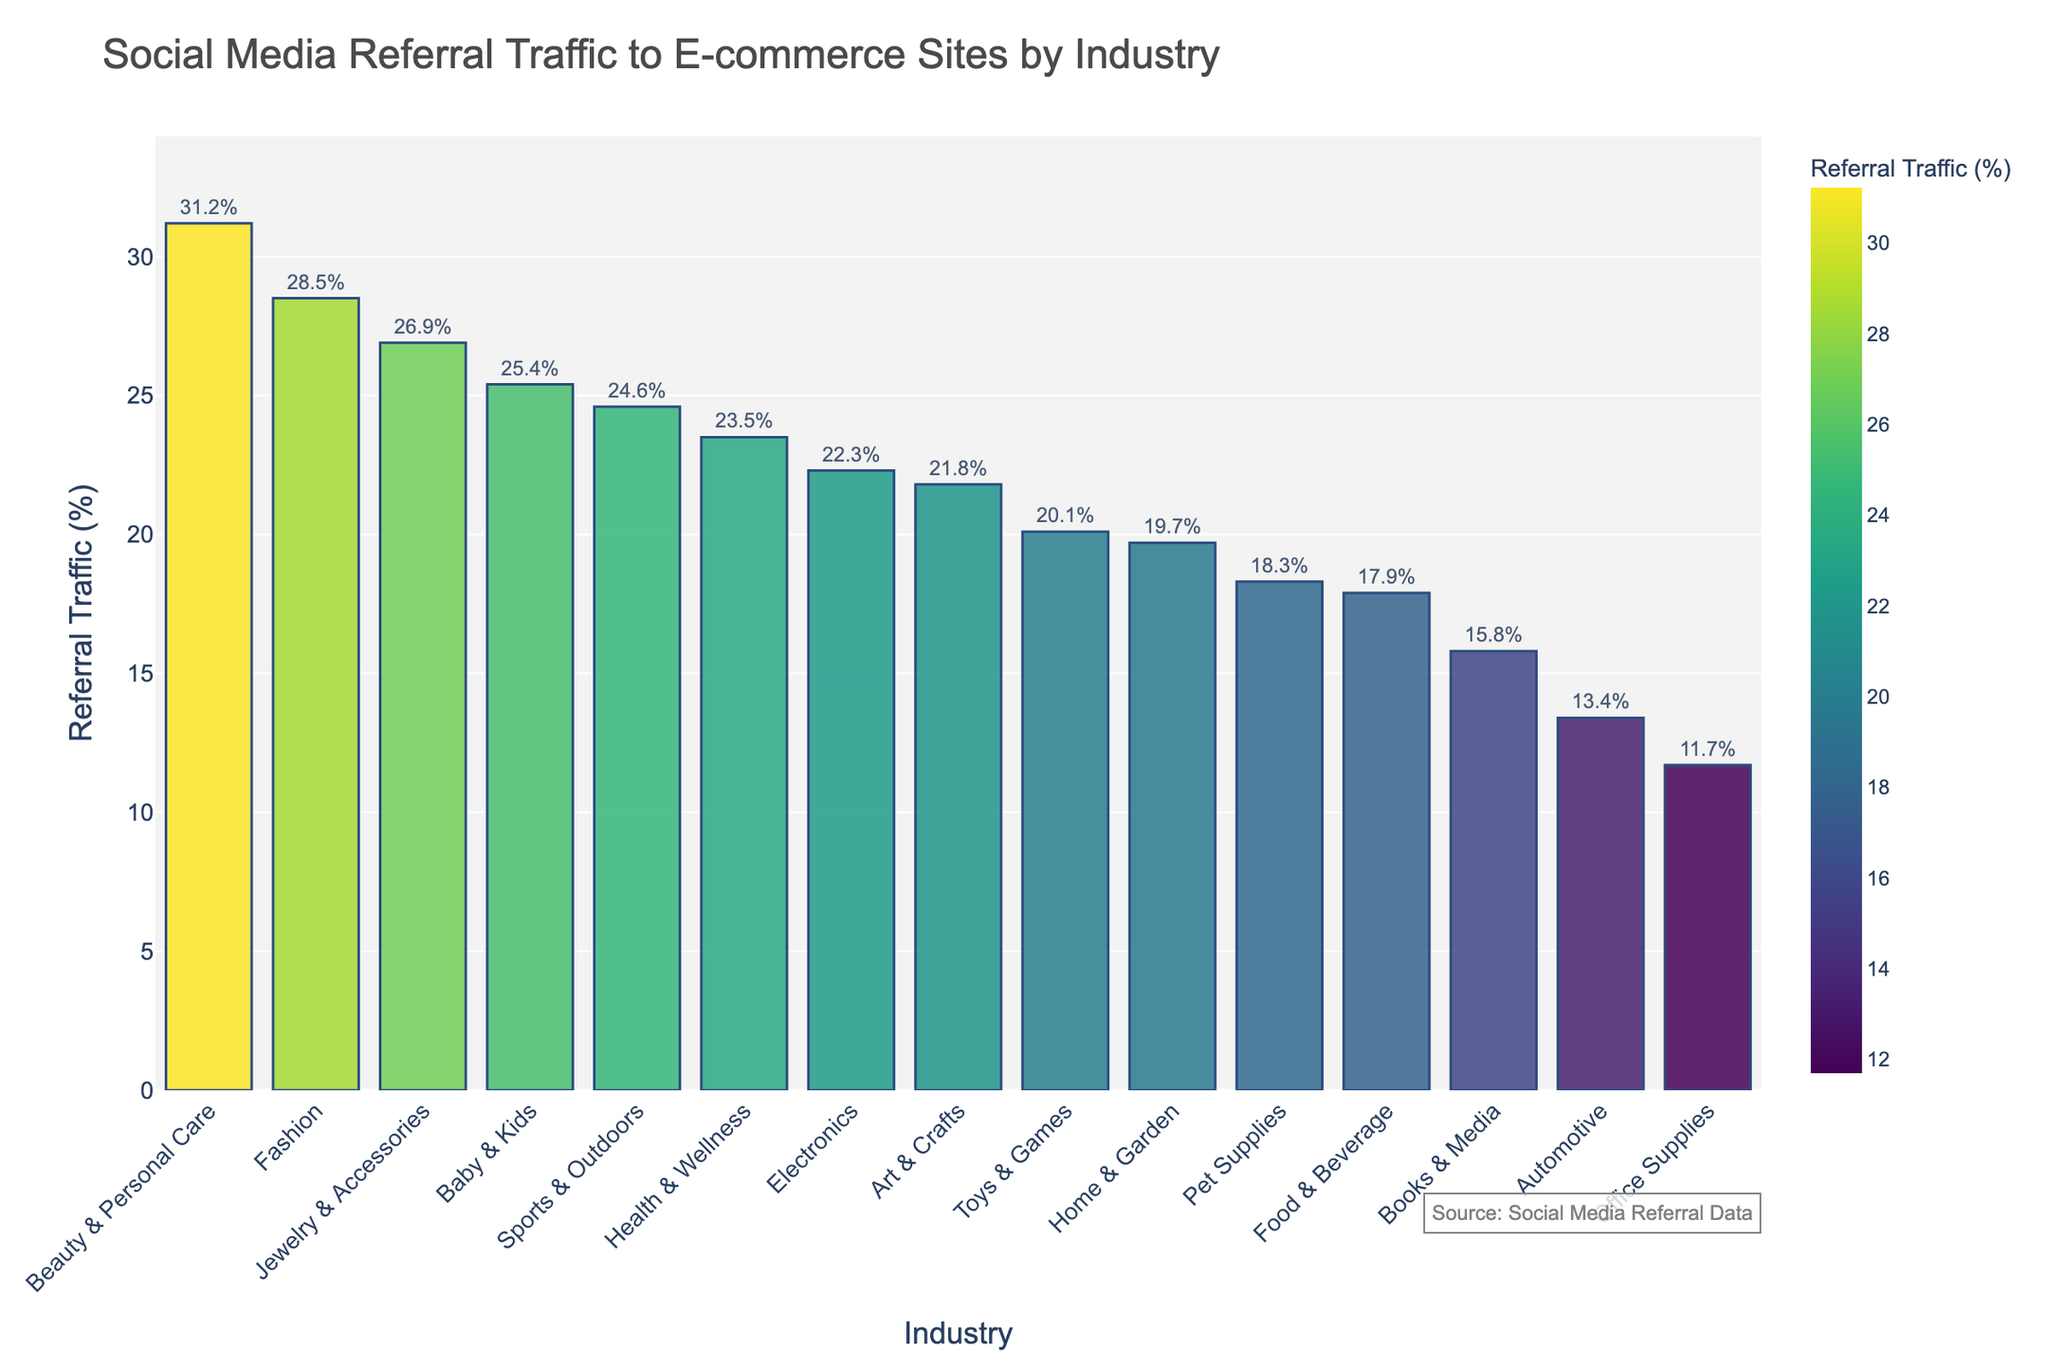Which industry has the highest referral traffic percentage? By observing the bar chart, the bar for 'Beauty & Personal Care' is the tallest, indicating the highest referral traffic percentage.
Answer: Beauty & Personal Care Which industry has the second highest referral traffic percentage? The bar chart shows that the second tallest bar belongs to 'Fashion,' which means it has the second highest referral traffic percentage.
Answer: Fashion Which industry has the lowest referral traffic percentage? By looking at the shortest bar in the chart, we can see that 'Office Supplies' has the lowest referral traffic percentage.
Answer: Office Supplies What is the combined referral traffic percentage for Fashion and Beauty & Personal Care? Add the referral traffic percentages for 'Fashion' (28.5%) and 'Beauty & Personal Care' (31.2%). So, 28.5% + 31.2% = 59.7%.
Answer: 59.7% How does referral traffic percentage for Toys & Games compare to Automotive? By comparing the heights of the bars for 'Toys & Games' (20.1%) and 'Automotive' (13.4%), 'Toys & Games' has a higher referral traffic percentage.
Answer: Toys & Games > Automotive Which has more referral traffic: Home & Garden or Health & Wellness? By comparing the bar heights, 'Health & Wellness' (23.5%) has a higher referral traffic percentage than 'Home & Garden' (19.7%).
Answer: Health & Wellness Is the referral traffic percentage for Sports & Outdoors greater than 20%? Observing the bar for 'Sports & Outdoors', we see its height corresponds to 24.6%, which is greater than 20%.
Answer: Yes What is the average referral traffic percentage for the top three industries? The top three industries are 'Beauty & Personal Care' (31.2%), 'Fashion' (28.5%), and 'Jewelry & Accessories' (26.9%). Calculate their average: (31.2 + 28.5 + 26.9) / 3 = 28.87%.
Answer: 28.87% What is the difference in referral traffic percentage between Electronics and Food & Beverage? Subtract 'Food & Beverage' percentage (17.9%) from 'Electronics' (22.3%): 22.3% - 17.9% = 4.4%.
Answer: 4.4% What is the sum of the referral traffic percentages for all industries? Add all the percentages for each industry: 28.5 + 22.3 + 19.7 + 31.2 + 17.9 + 24.6 + 20.1 + 15.8 + 13.4 + 26.9 + 18.3 + 23.5 + 11.7 + 21.8 + 25.4 = 321.1%.
Answer: 321.1% 